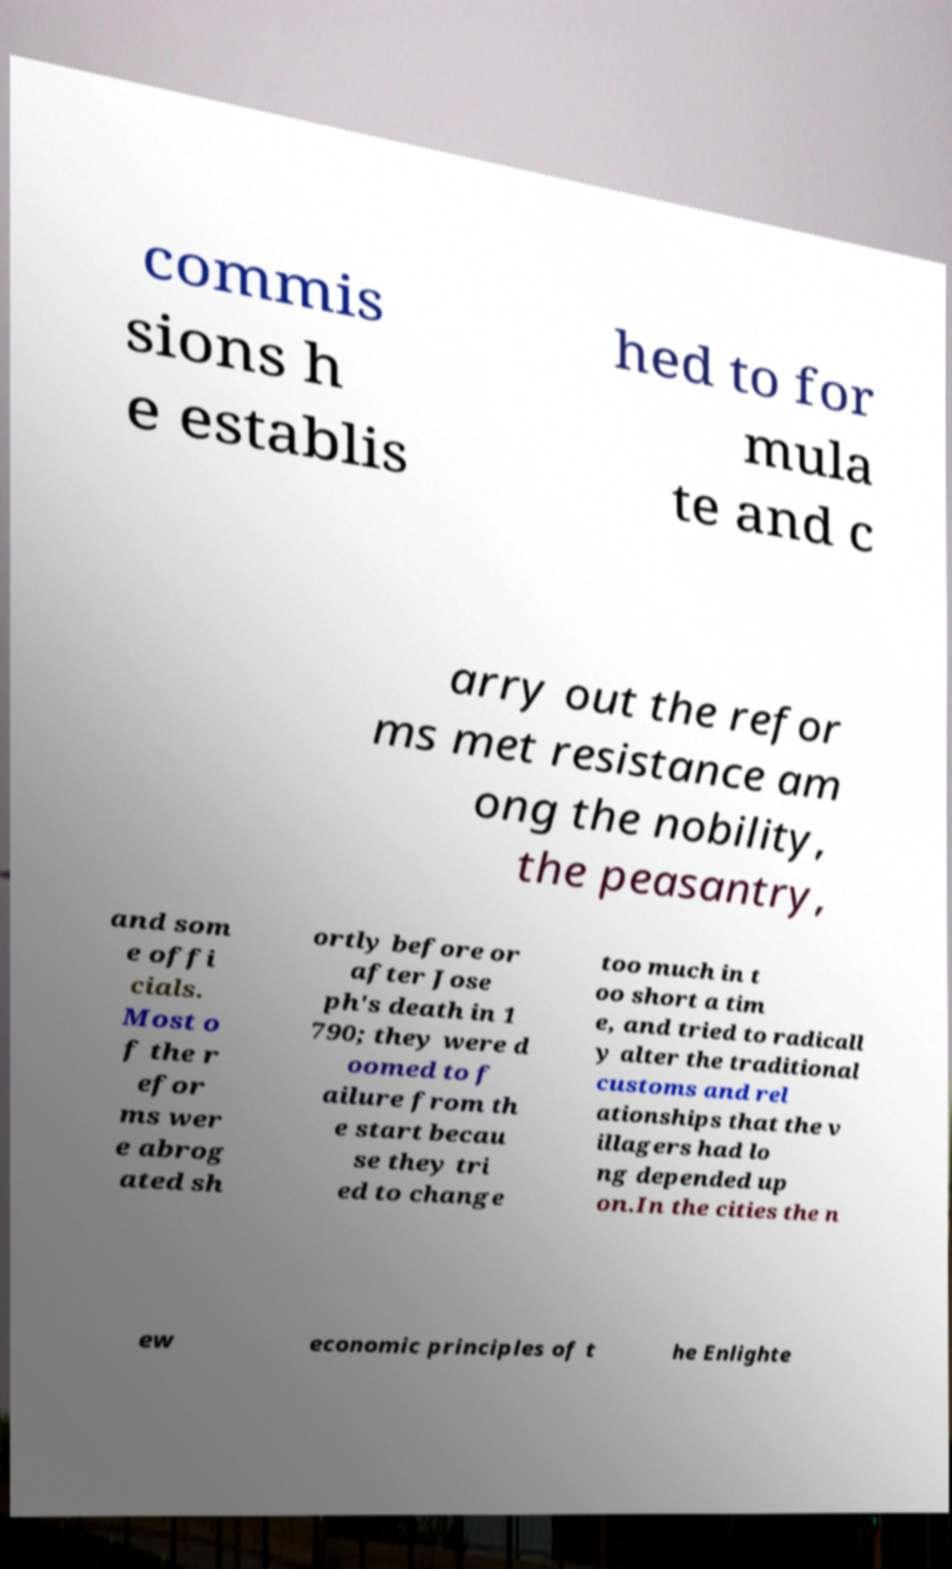I need the written content from this picture converted into text. Can you do that? commis sions h e establis hed to for mula te and c arry out the refor ms met resistance am ong the nobility, the peasantry, and som e offi cials. Most o f the r efor ms wer e abrog ated sh ortly before or after Jose ph's death in 1 790; they were d oomed to f ailure from th e start becau se they tri ed to change too much in t oo short a tim e, and tried to radicall y alter the traditional customs and rel ationships that the v illagers had lo ng depended up on.In the cities the n ew economic principles of t he Enlighte 